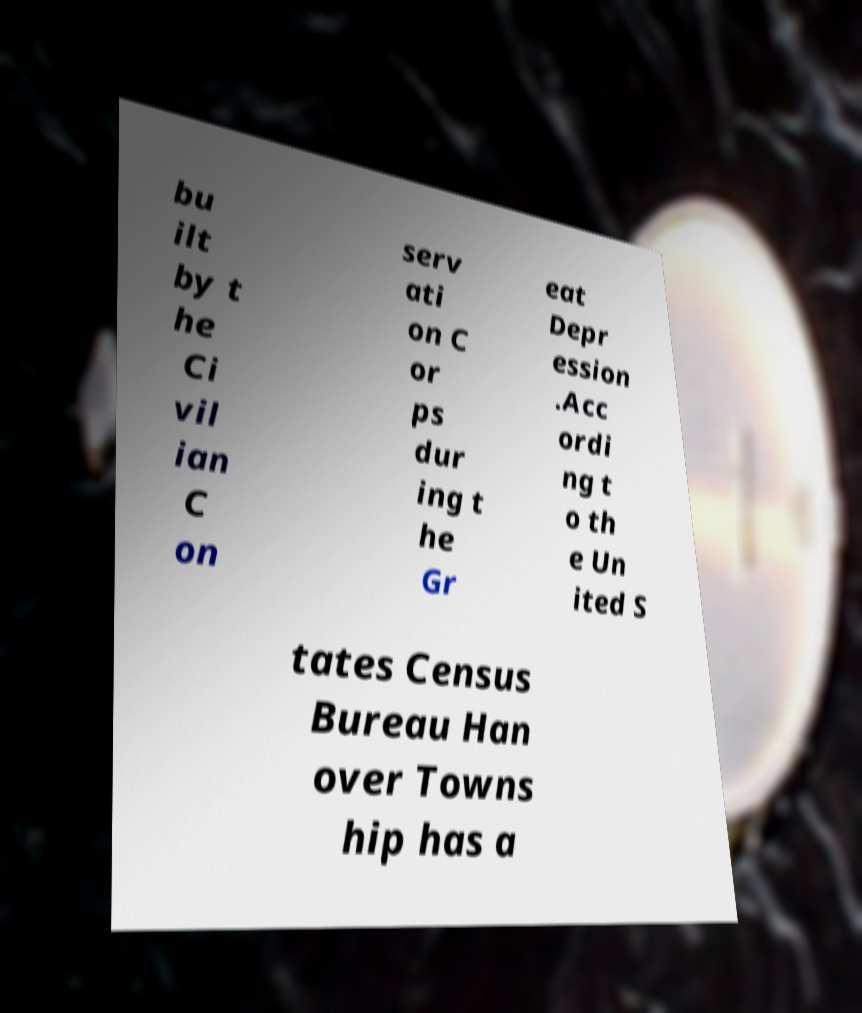Can you accurately transcribe the text from the provided image for me? bu ilt by t he Ci vil ian C on serv ati on C or ps dur ing t he Gr eat Depr ession .Acc ordi ng t o th e Un ited S tates Census Bureau Han over Towns hip has a 